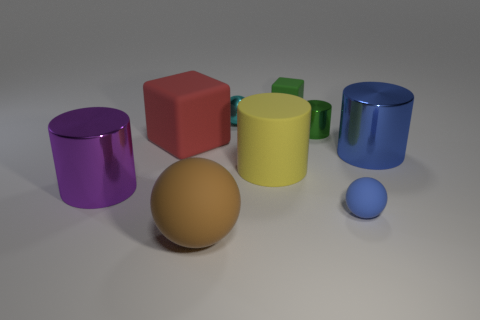Subtract all small green cylinders. How many cylinders are left? 3 Subtract all yellow cylinders. How many cylinders are left? 3 Add 1 large matte objects. How many objects exist? 10 Subtract all brown cylinders. Subtract all blue spheres. How many cylinders are left? 4 Subtract all balls. How many objects are left? 6 Add 4 balls. How many balls are left? 7 Add 9 cyan balls. How many cyan balls exist? 10 Subtract 0 gray blocks. How many objects are left? 9 Subtract all small yellow metal things. Subtract all tiny blue rubber spheres. How many objects are left? 8 